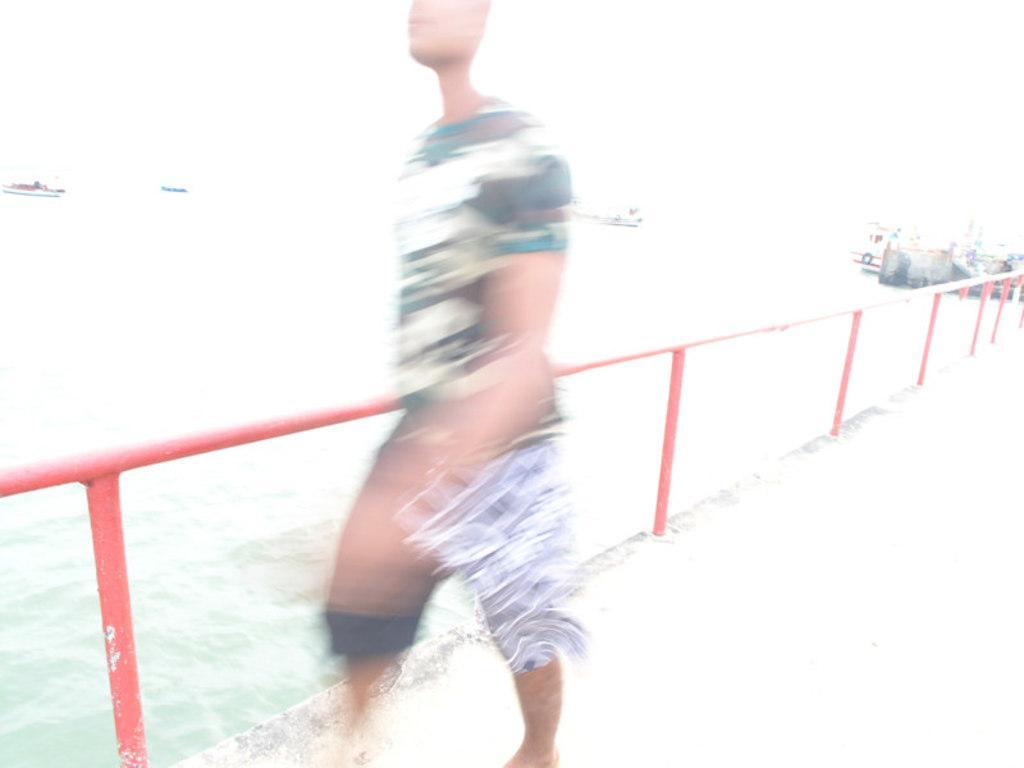Could you give a brief overview of what you see in this image? In front of the image there is a blur image of a person. Behind the person there is railing. Behind the railing there is water. There are few other things in the background. 